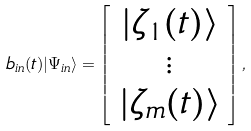Convert formula to latex. <formula><loc_0><loc_0><loc_500><loc_500>b _ { i n } ( t ) | \Psi _ { i n } \rangle = \left [ \begin{array} { c } | \zeta _ { 1 } ( t ) \rangle \\ \vdots \\ | \zeta _ { m } ( t ) \rangle \end{array} \right ] ,</formula> 